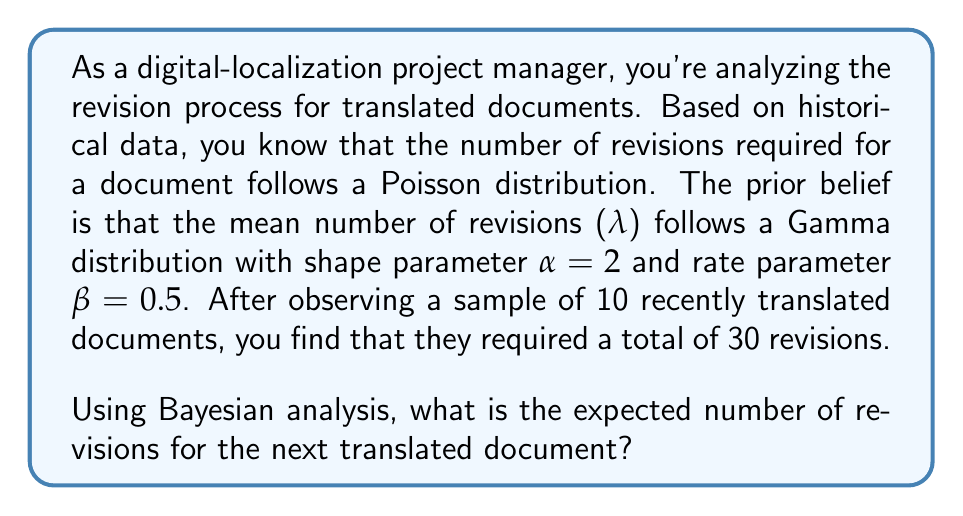Can you answer this question? Let's approach this step-by-step using Bayesian analysis:

1) Prior distribution:
   The prior for λ is Gamma(α, β) with α = 2 and β = 0.5.
   
2) Likelihood:
   The likelihood is Poisson(λ) for each document. For n documents with a total of x revisions, the likelihood is proportional to a Poisson(nλ) distribution.

3) Posterior distribution:
   When the prior is Gamma and the likelihood is Poisson, the posterior is also Gamma. The parameters of the posterior Gamma distribution are:
   
   $$α_{post} = α_{prior} + x$$
   $$β_{post} = β_{prior} + n$$

   Where x is the total number of revisions and n is the number of documents.

4) Calculating posterior parameters:
   $$α_{post} = 2 + 30 = 32$$
   $$β_{post} = 0.5 + 10 = 10.5$$

5) The posterior distribution for λ is thus Gamma(32, 10.5).

6) The expected value of a Gamma(α, β) distribution is α/β.

7) Therefore, the expected number of revisions for the next document is:

   $$E[λ|data] = \frac{α_{post}}{β_{post}} = \frac{32}{10.5} \approx 3.048$$

This is our best estimate for the number of revisions required for the next document, given our prior beliefs and the observed data.
Answer: The expected number of revisions for the next translated document is approximately 3.048. 